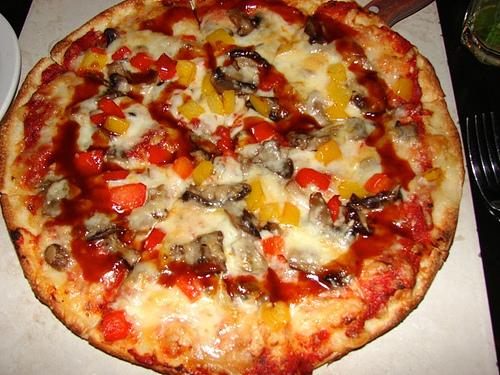Is this pizza ready to eat?
Concise answer only. Yes. Is there sauce?
Short answer required. Yes. Is this pizza vegan friendly?
Write a very short answer. Yes. 